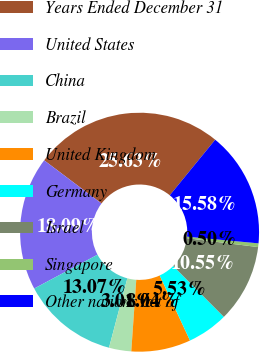<chart> <loc_0><loc_0><loc_500><loc_500><pie_chart><fcel>Years Ended December 31<fcel>United States<fcel>China<fcel>Brazil<fcel>United Kingdom<fcel>Germany<fcel>Israel<fcel>Singapore<fcel>Other nations net of<nl><fcel>25.63%<fcel>18.09%<fcel>13.07%<fcel>3.01%<fcel>8.04%<fcel>5.53%<fcel>10.55%<fcel>0.5%<fcel>15.58%<nl></chart> 